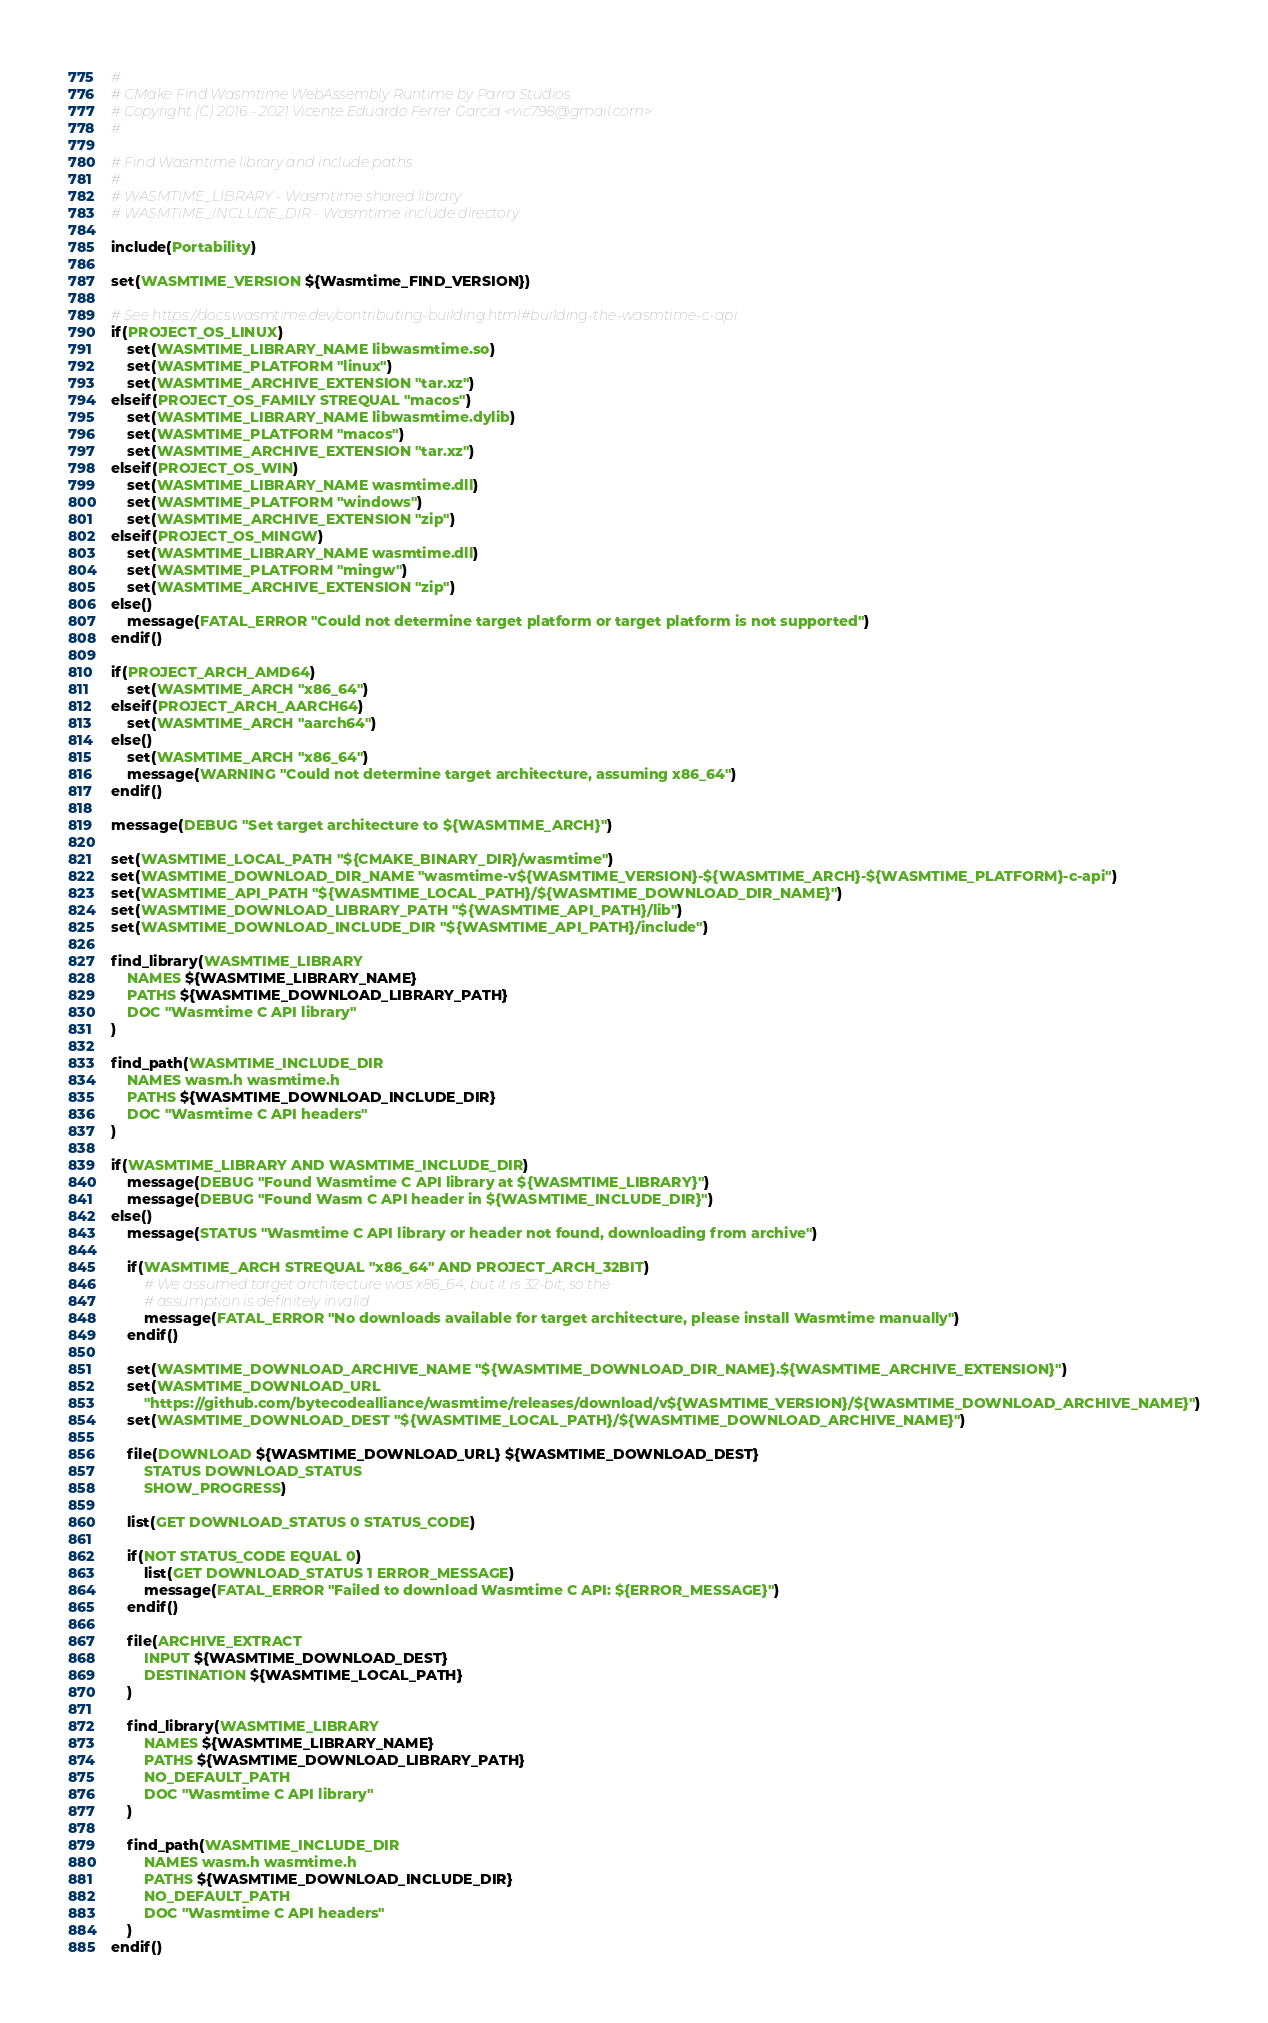<code> <loc_0><loc_0><loc_500><loc_500><_CMake_>#
# CMake Find Wasmtime WebAssembly Runtime by Parra Studios
# Copyright (C) 2016 - 2021 Vicente Eduardo Ferrer Garcia <vic798@gmail.com>
#

# Find Wasmtime library and include paths
#
# WASMTIME_LIBRARY - Wasmtime shared library
# WASMTIME_INCLUDE_DIR - Wasmtime include directory

include(Portability)

set(WASMTIME_VERSION ${Wasmtime_FIND_VERSION})

# See https://docs.wasmtime.dev/contributing-building.html#building-the-wasmtime-c-api
if(PROJECT_OS_LINUX)
	set(WASMTIME_LIBRARY_NAME libwasmtime.so)
	set(WASMTIME_PLATFORM "linux")
	set(WASMTIME_ARCHIVE_EXTENSION "tar.xz")
elseif(PROJECT_OS_FAMILY STREQUAL "macos")
	set(WASMTIME_LIBRARY_NAME libwasmtime.dylib)
	set(WASMTIME_PLATFORM "macos")
	set(WASMTIME_ARCHIVE_EXTENSION "tar.xz")
elseif(PROJECT_OS_WIN)
	set(WASMTIME_LIBRARY_NAME wasmtime.dll)
	set(WASMTIME_PLATFORM "windows")
	set(WASMTIME_ARCHIVE_EXTENSION "zip")
elseif(PROJECT_OS_MINGW)
	set(WASMTIME_LIBRARY_NAME wasmtime.dll)
	set(WASMTIME_PLATFORM "mingw")
	set(WASMTIME_ARCHIVE_EXTENSION "zip")
else()
	message(FATAL_ERROR "Could not determine target platform or target platform is not supported")
endif()

if(PROJECT_ARCH_AMD64)
	set(WASMTIME_ARCH "x86_64")
elseif(PROJECT_ARCH_AARCH64)
	set(WASMTIME_ARCH "aarch64")
else()
	set(WASMTIME_ARCH "x86_64")
	message(WARNING "Could not determine target architecture, assuming x86_64")
endif()

message(DEBUG "Set target architecture to ${WASMTIME_ARCH}")

set(WASMTIME_LOCAL_PATH "${CMAKE_BINARY_DIR}/wasmtime")
set(WASMTIME_DOWNLOAD_DIR_NAME "wasmtime-v${WASMTIME_VERSION}-${WASMTIME_ARCH}-${WASMTIME_PLATFORM}-c-api")
set(WASMTIME_API_PATH "${WASMTIME_LOCAL_PATH}/${WASMTIME_DOWNLOAD_DIR_NAME}")
set(WASMTIME_DOWNLOAD_LIBRARY_PATH "${WASMTIME_API_PATH}/lib")
set(WASMTIME_DOWNLOAD_INCLUDE_DIR "${WASMTIME_API_PATH}/include")

find_library(WASMTIME_LIBRARY
	NAMES ${WASMTIME_LIBRARY_NAME}
	PATHS ${WASMTIME_DOWNLOAD_LIBRARY_PATH}
	DOC "Wasmtime C API library"
)

find_path(WASMTIME_INCLUDE_DIR
	NAMES wasm.h wasmtime.h
	PATHS ${WASMTIME_DOWNLOAD_INCLUDE_DIR}
	DOC "Wasmtime C API headers"
)

if(WASMTIME_LIBRARY AND WASMTIME_INCLUDE_DIR)
	message(DEBUG "Found Wasmtime C API library at ${WASMTIME_LIBRARY}")
	message(DEBUG "Found Wasm C API header in ${WASMTIME_INCLUDE_DIR}")
else()
	message(STATUS "Wasmtime C API library or header not found, downloading from archive")

	if(WASMTIME_ARCH STREQUAL "x86_64" AND PROJECT_ARCH_32BIT)
		# We assumed target architecture was x86_64, but it is 32-bit, so the
		# assumption is definitely invalid.
		message(FATAL_ERROR "No downloads available for target architecture, please install Wasmtime manually")
	endif()

	set(WASMTIME_DOWNLOAD_ARCHIVE_NAME "${WASMTIME_DOWNLOAD_DIR_NAME}.${WASMTIME_ARCHIVE_EXTENSION}")
	set(WASMTIME_DOWNLOAD_URL
		"https://github.com/bytecodealliance/wasmtime/releases/download/v${WASMTIME_VERSION}/${WASMTIME_DOWNLOAD_ARCHIVE_NAME}")
	set(WASMTIME_DOWNLOAD_DEST "${WASMTIME_LOCAL_PATH}/${WASMTIME_DOWNLOAD_ARCHIVE_NAME}")

	file(DOWNLOAD ${WASMTIME_DOWNLOAD_URL} ${WASMTIME_DOWNLOAD_DEST}
		STATUS DOWNLOAD_STATUS
		SHOW_PROGRESS)

	list(GET DOWNLOAD_STATUS 0 STATUS_CODE)

	if(NOT STATUS_CODE EQUAL 0)
		list(GET DOWNLOAD_STATUS 1 ERROR_MESSAGE)
		message(FATAL_ERROR "Failed to download Wasmtime C API: ${ERROR_MESSAGE}")
	endif()

	file(ARCHIVE_EXTRACT
		INPUT ${WASMTIME_DOWNLOAD_DEST}
		DESTINATION ${WASMTIME_LOCAL_PATH}
	)

	find_library(WASMTIME_LIBRARY
		NAMES ${WASMTIME_LIBRARY_NAME}
		PATHS ${WASMTIME_DOWNLOAD_LIBRARY_PATH}
		NO_DEFAULT_PATH
		DOC "Wasmtime C API library"
	)

	find_path(WASMTIME_INCLUDE_DIR
		NAMES wasm.h wasmtime.h
		PATHS ${WASMTIME_DOWNLOAD_INCLUDE_DIR}
		NO_DEFAULT_PATH
		DOC "Wasmtime C API headers"
	)
endif()
</code> 